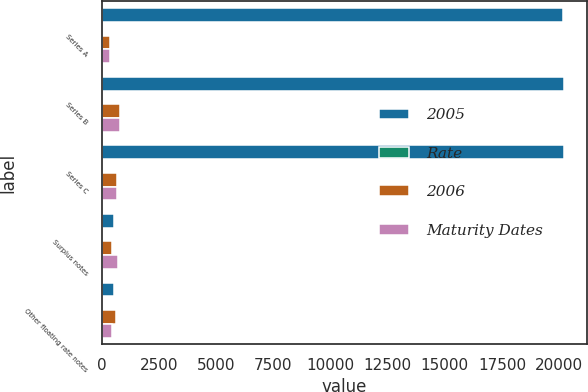Convert chart to OTSL. <chart><loc_0><loc_0><loc_500><loc_500><stacked_bar_chart><ecel><fcel>Series A<fcel>Series B<fcel>Series C<fcel>Surplus notes<fcel>Other floating rate notes<nl><fcel>2005<fcel>20171<fcel>20231<fcel>20231<fcel>527<fcel>527<nl><fcel>Rate<fcel>2<fcel>7.25<fcel>8.7<fcel>3<fcel>5<nl><fcel>2006<fcel>333<fcel>777<fcel>640<fcel>443<fcel>604<nl><fcel>Maturity Dates<fcel>333<fcel>777<fcel>640<fcel>693<fcel>450<nl></chart> 